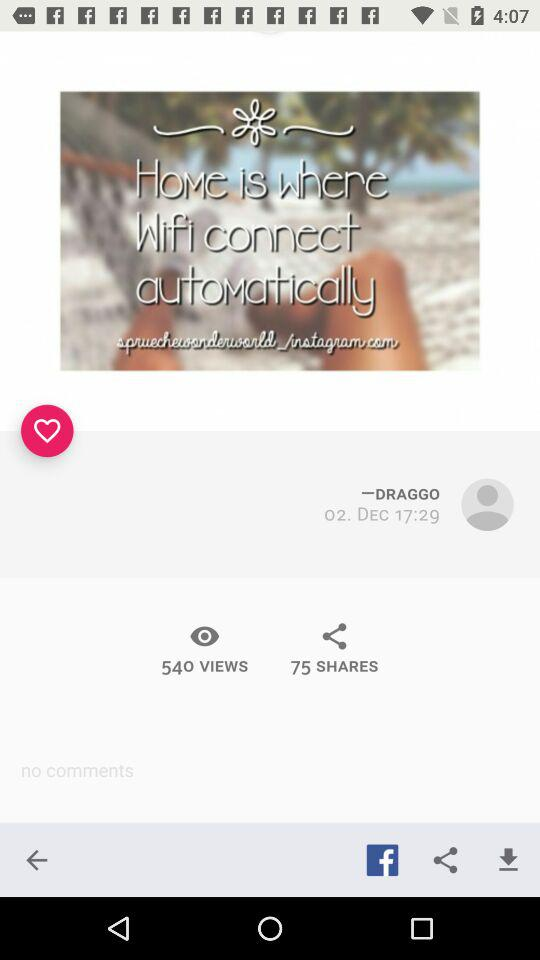How many more people have viewed this post than shared it?
Answer the question using a single word or phrase. 465 